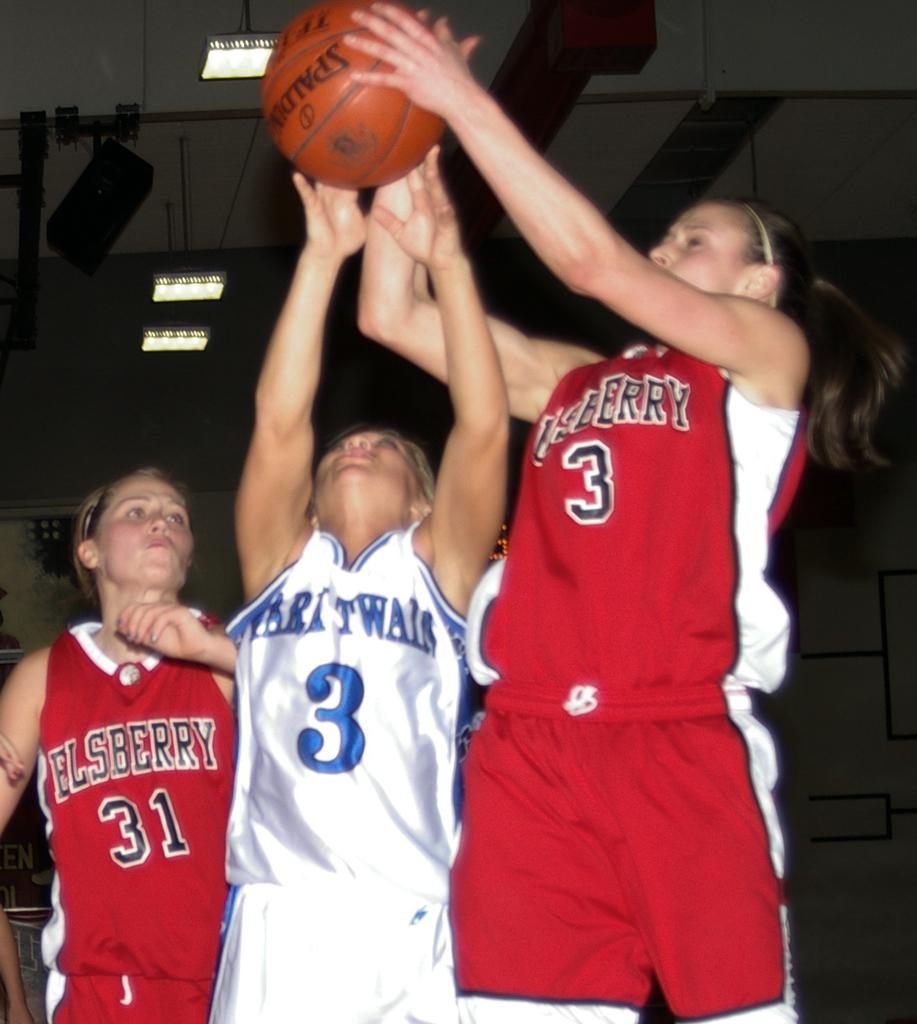Provide a one-sentence caption for the provided image. Number 3 for Elsberry takes the rebound over the oppostion's number 3. 